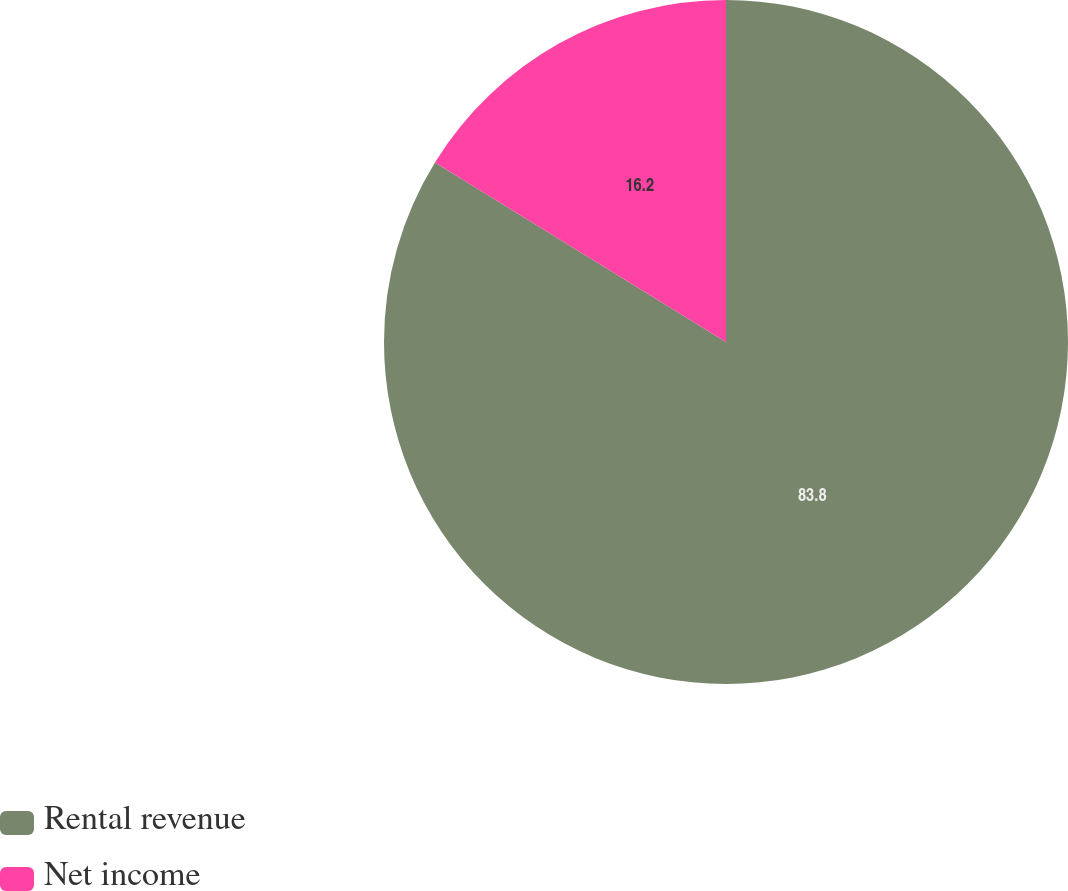Convert chart to OTSL. <chart><loc_0><loc_0><loc_500><loc_500><pie_chart><fcel>Rental revenue<fcel>Net income<nl><fcel>83.8%<fcel>16.2%<nl></chart> 